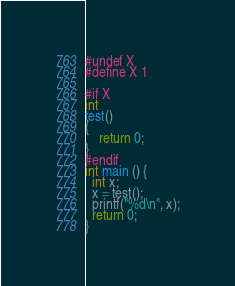Convert code to text. <code><loc_0><loc_0><loc_500><loc_500><_C_>
#undef X
#define X 1

#if X
int
test()
{
	return 0;
}
#endif
int main () {
  int x;
  x = test();
  printf("%d\n", x);
  return 0;
}</code> 